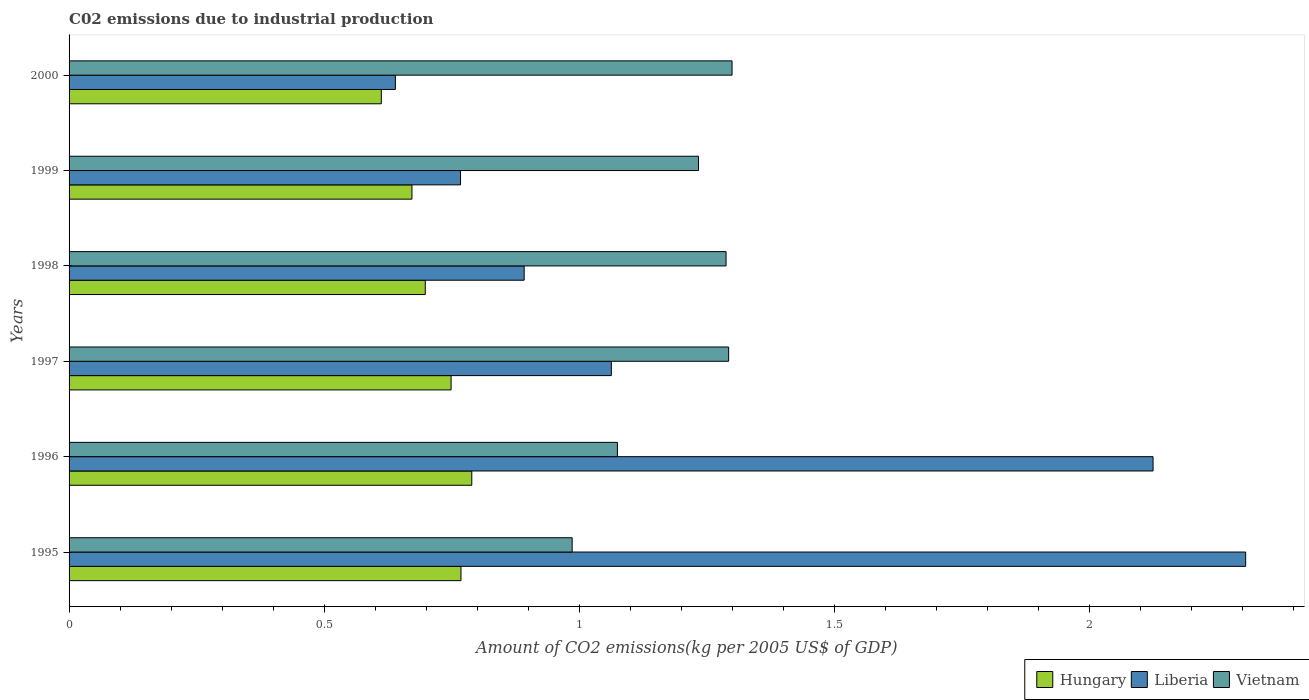How many different coloured bars are there?
Ensure brevity in your answer.  3. Are the number of bars per tick equal to the number of legend labels?
Provide a succinct answer. Yes. Are the number of bars on each tick of the Y-axis equal?
Make the answer very short. Yes. How many bars are there on the 5th tick from the top?
Your answer should be very brief. 3. How many bars are there on the 5th tick from the bottom?
Provide a succinct answer. 3. What is the amount of CO2 emitted due to industrial production in Liberia in 1996?
Your answer should be compact. 2.12. Across all years, what is the maximum amount of CO2 emitted due to industrial production in Hungary?
Ensure brevity in your answer.  0.79. Across all years, what is the minimum amount of CO2 emitted due to industrial production in Liberia?
Your response must be concise. 0.64. In which year was the amount of CO2 emitted due to industrial production in Vietnam maximum?
Provide a succinct answer. 2000. What is the total amount of CO2 emitted due to industrial production in Hungary in the graph?
Your answer should be compact. 4.29. What is the difference between the amount of CO2 emitted due to industrial production in Vietnam in 1995 and that in 2000?
Ensure brevity in your answer.  -0.31. What is the difference between the amount of CO2 emitted due to industrial production in Hungary in 1997 and the amount of CO2 emitted due to industrial production in Vietnam in 1999?
Offer a very short reply. -0.48. What is the average amount of CO2 emitted due to industrial production in Liberia per year?
Ensure brevity in your answer.  1.3. In the year 1995, what is the difference between the amount of CO2 emitted due to industrial production in Liberia and amount of CO2 emitted due to industrial production in Hungary?
Your response must be concise. 1.54. In how many years, is the amount of CO2 emitted due to industrial production in Vietnam greater than 1 kg?
Make the answer very short. 5. What is the ratio of the amount of CO2 emitted due to industrial production in Hungary in 1996 to that in 1999?
Your response must be concise. 1.17. Is the amount of CO2 emitted due to industrial production in Vietnam in 1995 less than that in 1999?
Your answer should be very brief. Yes. What is the difference between the highest and the second highest amount of CO2 emitted due to industrial production in Hungary?
Your answer should be compact. 0.02. What is the difference between the highest and the lowest amount of CO2 emitted due to industrial production in Hungary?
Provide a succinct answer. 0.18. Is the sum of the amount of CO2 emitted due to industrial production in Hungary in 1998 and 2000 greater than the maximum amount of CO2 emitted due to industrial production in Liberia across all years?
Your response must be concise. No. What does the 1st bar from the top in 1998 represents?
Make the answer very short. Vietnam. What does the 2nd bar from the bottom in 1999 represents?
Keep it short and to the point. Liberia. How many bars are there?
Ensure brevity in your answer.  18. Are all the bars in the graph horizontal?
Your answer should be very brief. Yes. What is the difference between two consecutive major ticks on the X-axis?
Provide a succinct answer. 0.5. Are the values on the major ticks of X-axis written in scientific E-notation?
Make the answer very short. No. Does the graph contain any zero values?
Your answer should be compact. No. How are the legend labels stacked?
Provide a short and direct response. Horizontal. What is the title of the graph?
Keep it short and to the point. C02 emissions due to industrial production. Does "Turkmenistan" appear as one of the legend labels in the graph?
Your response must be concise. No. What is the label or title of the X-axis?
Your answer should be compact. Amount of CO2 emissions(kg per 2005 US$ of GDP). What is the label or title of the Y-axis?
Make the answer very short. Years. What is the Amount of CO2 emissions(kg per 2005 US$ of GDP) in Hungary in 1995?
Offer a terse response. 0.77. What is the Amount of CO2 emissions(kg per 2005 US$ of GDP) of Liberia in 1995?
Make the answer very short. 2.31. What is the Amount of CO2 emissions(kg per 2005 US$ of GDP) in Vietnam in 1995?
Keep it short and to the point. 0.99. What is the Amount of CO2 emissions(kg per 2005 US$ of GDP) of Hungary in 1996?
Offer a very short reply. 0.79. What is the Amount of CO2 emissions(kg per 2005 US$ of GDP) of Liberia in 1996?
Ensure brevity in your answer.  2.12. What is the Amount of CO2 emissions(kg per 2005 US$ of GDP) in Vietnam in 1996?
Your response must be concise. 1.07. What is the Amount of CO2 emissions(kg per 2005 US$ of GDP) in Hungary in 1997?
Provide a short and direct response. 0.75. What is the Amount of CO2 emissions(kg per 2005 US$ of GDP) of Liberia in 1997?
Make the answer very short. 1.06. What is the Amount of CO2 emissions(kg per 2005 US$ of GDP) of Vietnam in 1997?
Ensure brevity in your answer.  1.29. What is the Amount of CO2 emissions(kg per 2005 US$ of GDP) in Hungary in 1998?
Your answer should be compact. 0.7. What is the Amount of CO2 emissions(kg per 2005 US$ of GDP) of Liberia in 1998?
Offer a very short reply. 0.89. What is the Amount of CO2 emissions(kg per 2005 US$ of GDP) of Vietnam in 1998?
Keep it short and to the point. 1.29. What is the Amount of CO2 emissions(kg per 2005 US$ of GDP) of Hungary in 1999?
Provide a short and direct response. 0.67. What is the Amount of CO2 emissions(kg per 2005 US$ of GDP) of Liberia in 1999?
Keep it short and to the point. 0.77. What is the Amount of CO2 emissions(kg per 2005 US$ of GDP) of Vietnam in 1999?
Make the answer very short. 1.23. What is the Amount of CO2 emissions(kg per 2005 US$ of GDP) in Hungary in 2000?
Give a very brief answer. 0.61. What is the Amount of CO2 emissions(kg per 2005 US$ of GDP) in Liberia in 2000?
Offer a very short reply. 0.64. What is the Amount of CO2 emissions(kg per 2005 US$ of GDP) in Vietnam in 2000?
Make the answer very short. 1.3. Across all years, what is the maximum Amount of CO2 emissions(kg per 2005 US$ of GDP) of Hungary?
Your answer should be very brief. 0.79. Across all years, what is the maximum Amount of CO2 emissions(kg per 2005 US$ of GDP) of Liberia?
Make the answer very short. 2.31. Across all years, what is the maximum Amount of CO2 emissions(kg per 2005 US$ of GDP) of Vietnam?
Offer a terse response. 1.3. Across all years, what is the minimum Amount of CO2 emissions(kg per 2005 US$ of GDP) of Hungary?
Give a very brief answer. 0.61. Across all years, what is the minimum Amount of CO2 emissions(kg per 2005 US$ of GDP) of Liberia?
Make the answer very short. 0.64. Across all years, what is the minimum Amount of CO2 emissions(kg per 2005 US$ of GDP) in Vietnam?
Provide a succinct answer. 0.99. What is the total Amount of CO2 emissions(kg per 2005 US$ of GDP) of Hungary in the graph?
Provide a succinct answer. 4.29. What is the total Amount of CO2 emissions(kg per 2005 US$ of GDP) in Liberia in the graph?
Give a very brief answer. 7.79. What is the total Amount of CO2 emissions(kg per 2005 US$ of GDP) in Vietnam in the graph?
Your answer should be compact. 7.17. What is the difference between the Amount of CO2 emissions(kg per 2005 US$ of GDP) of Hungary in 1995 and that in 1996?
Keep it short and to the point. -0.02. What is the difference between the Amount of CO2 emissions(kg per 2005 US$ of GDP) of Liberia in 1995 and that in 1996?
Offer a very short reply. 0.18. What is the difference between the Amount of CO2 emissions(kg per 2005 US$ of GDP) in Vietnam in 1995 and that in 1996?
Keep it short and to the point. -0.09. What is the difference between the Amount of CO2 emissions(kg per 2005 US$ of GDP) of Hungary in 1995 and that in 1997?
Ensure brevity in your answer.  0.02. What is the difference between the Amount of CO2 emissions(kg per 2005 US$ of GDP) of Liberia in 1995 and that in 1997?
Your answer should be very brief. 1.24. What is the difference between the Amount of CO2 emissions(kg per 2005 US$ of GDP) in Vietnam in 1995 and that in 1997?
Your answer should be compact. -0.31. What is the difference between the Amount of CO2 emissions(kg per 2005 US$ of GDP) of Hungary in 1995 and that in 1998?
Ensure brevity in your answer.  0.07. What is the difference between the Amount of CO2 emissions(kg per 2005 US$ of GDP) in Liberia in 1995 and that in 1998?
Your answer should be very brief. 1.41. What is the difference between the Amount of CO2 emissions(kg per 2005 US$ of GDP) of Vietnam in 1995 and that in 1998?
Keep it short and to the point. -0.3. What is the difference between the Amount of CO2 emissions(kg per 2005 US$ of GDP) in Hungary in 1995 and that in 1999?
Make the answer very short. 0.1. What is the difference between the Amount of CO2 emissions(kg per 2005 US$ of GDP) in Liberia in 1995 and that in 1999?
Offer a terse response. 1.54. What is the difference between the Amount of CO2 emissions(kg per 2005 US$ of GDP) of Vietnam in 1995 and that in 1999?
Keep it short and to the point. -0.25. What is the difference between the Amount of CO2 emissions(kg per 2005 US$ of GDP) in Hungary in 1995 and that in 2000?
Ensure brevity in your answer.  0.16. What is the difference between the Amount of CO2 emissions(kg per 2005 US$ of GDP) in Liberia in 1995 and that in 2000?
Offer a very short reply. 1.67. What is the difference between the Amount of CO2 emissions(kg per 2005 US$ of GDP) of Vietnam in 1995 and that in 2000?
Make the answer very short. -0.31. What is the difference between the Amount of CO2 emissions(kg per 2005 US$ of GDP) in Hungary in 1996 and that in 1997?
Offer a terse response. 0.04. What is the difference between the Amount of CO2 emissions(kg per 2005 US$ of GDP) in Liberia in 1996 and that in 1997?
Offer a terse response. 1.06. What is the difference between the Amount of CO2 emissions(kg per 2005 US$ of GDP) of Vietnam in 1996 and that in 1997?
Keep it short and to the point. -0.22. What is the difference between the Amount of CO2 emissions(kg per 2005 US$ of GDP) of Hungary in 1996 and that in 1998?
Provide a succinct answer. 0.09. What is the difference between the Amount of CO2 emissions(kg per 2005 US$ of GDP) of Liberia in 1996 and that in 1998?
Provide a succinct answer. 1.23. What is the difference between the Amount of CO2 emissions(kg per 2005 US$ of GDP) in Vietnam in 1996 and that in 1998?
Ensure brevity in your answer.  -0.21. What is the difference between the Amount of CO2 emissions(kg per 2005 US$ of GDP) in Hungary in 1996 and that in 1999?
Make the answer very short. 0.12. What is the difference between the Amount of CO2 emissions(kg per 2005 US$ of GDP) in Liberia in 1996 and that in 1999?
Offer a terse response. 1.36. What is the difference between the Amount of CO2 emissions(kg per 2005 US$ of GDP) in Vietnam in 1996 and that in 1999?
Keep it short and to the point. -0.16. What is the difference between the Amount of CO2 emissions(kg per 2005 US$ of GDP) in Hungary in 1996 and that in 2000?
Your answer should be very brief. 0.18. What is the difference between the Amount of CO2 emissions(kg per 2005 US$ of GDP) in Liberia in 1996 and that in 2000?
Your response must be concise. 1.48. What is the difference between the Amount of CO2 emissions(kg per 2005 US$ of GDP) of Vietnam in 1996 and that in 2000?
Give a very brief answer. -0.22. What is the difference between the Amount of CO2 emissions(kg per 2005 US$ of GDP) in Hungary in 1997 and that in 1998?
Provide a short and direct response. 0.05. What is the difference between the Amount of CO2 emissions(kg per 2005 US$ of GDP) of Liberia in 1997 and that in 1998?
Provide a succinct answer. 0.17. What is the difference between the Amount of CO2 emissions(kg per 2005 US$ of GDP) of Vietnam in 1997 and that in 1998?
Keep it short and to the point. 0.01. What is the difference between the Amount of CO2 emissions(kg per 2005 US$ of GDP) of Hungary in 1997 and that in 1999?
Offer a very short reply. 0.08. What is the difference between the Amount of CO2 emissions(kg per 2005 US$ of GDP) in Liberia in 1997 and that in 1999?
Your response must be concise. 0.3. What is the difference between the Amount of CO2 emissions(kg per 2005 US$ of GDP) in Vietnam in 1997 and that in 1999?
Give a very brief answer. 0.06. What is the difference between the Amount of CO2 emissions(kg per 2005 US$ of GDP) of Hungary in 1997 and that in 2000?
Offer a terse response. 0.14. What is the difference between the Amount of CO2 emissions(kg per 2005 US$ of GDP) in Liberia in 1997 and that in 2000?
Provide a short and direct response. 0.42. What is the difference between the Amount of CO2 emissions(kg per 2005 US$ of GDP) of Vietnam in 1997 and that in 2000?
Your answer should be compact. -0.01. What is the difference between the Amount of CO2 emissions(kg per 2005 US$ of GDP) in Hungary in 1998 and that in 1999?
Ensure brevity in your answer.  0.03. What is the difference between the Amount of CO2 emissions(kg per 2005 US$ of GDP) of Liberia in 1998 and that in 1999?
Your response must be concise. 0.12. What is the difference between the Amount of CO2 emissions(kg per 2005 US$ of GDP) in Vietnam in 1998 and that in 1999?
Keep it short and to the point. 0.05. What is the difference between the Amount of CO2 emissions(kg per 2005 US$ of GDP) of Hungary in 1998 and that in 2000?
Make the answer very short. 0.09. What is the difference between the Amount of CO2 emissions(kg per 2005 US$ of GDP) in Liberia in 1998 and that in 2000?
Keep it short and to the point. 0.25. What is the difference between the Amount of CO2 emissions(kg per 2005 US$ of GDP) in Vietnam in 1998 and that in 2000?
Provide a short and direct response. -0.01. What is the difference between the Amount of CO2 emissions(kg per 2005 US$ of GDP) of Hungary in 1999 and that in 2000?
Provide a short and direct response. 0.06. What is the difference between the Amount of CO2 emissions(kg per 2005 US$ of GDP) of Liberia in 1999 and that in 2000?
Your response must be concise. 0.13. What is the difference between the Amount of CO2 emissions(kg per 2005 US$ of GDP) of Vietnam in 1999 and that in 2000?
Your response must be concise. -0.07. What is the difference between the Amount of CO2 emissions(kg per 2005 US$ of GDP) in Hungary in 1995 and the Amount of CO2 emissions(kg per 2005 US$ of GDP) in Liberia in 1996?
Give a very brief answer. -1.36. What is the difference between the Amount of CO2 emissions(kg per 2005 US$ of GDP) in Hungary in 1995 and the Amount of CO2 emissions(kg per 2005 US$ of GDP) in Vietnam in 1996?
Make the answer very short. -0.31. What is the difference between the Amount of CO2 emissions(kg per 2005 US$ of GDP) of Liberia in 1995 and the Amount of CO2 emissions(kg per 2005 US$ of GDP) of Vietnam in 1996?
Your response must be concise. 1.23. What is the difference between the Amount of CO2 emissions(kg per 2005 US$ of GDP) of Hungary in 1995 and the Amount of CO2 emissions(kg per 2005 US$ of GDP) of Liberia in 1997?
Give a very brief answer. -0.29. What is the difference between the Amount of CO2 emissions(kg per 2005 US$ of GDP) in Hungary in 1995 and the Amount of CO2 emissions(kg per 2005 US$ of GDP) in Vietnam in 1997?
Your response must be concise. -0.52. What is the difference between the Amount of CO2 emissions(kg per 2005 US$ of GDP) of Liberia in 1995 and the Amount of CO2 emissions(kg per 2005 US$ of GDP) of Vietnam in 1997?
Offer a terse response. 1.01. What is the difference between the Amount of CO2 emissions(kg per 2005 US$ of GDP) in Hungary in 1995 and the Amount of CO2 emissions(kg per 2005 US$ of GDP) in Liberia in 1998?
Make the answer very short. -0.12. What is the difference between the Amount of CO2 emissions(kg per 2005 US$ of GDP) of Hungary in 1995 and the Amount of CO2 emissions(kg per 2005 US$ of GDP) of Vietnam in 1998?
Ensure brevity in your answer.  -0.52. What is the difference between the Amount of CO2 emissions(kg per 2005 US$ of GDP) of Liberia in 1995 and the Amount of CO2 emissions(kg per 2005 US$ of GDP) of Vietnam in 1998?
Your answer should be very brief. 1.02. What is the difference between the Amount of CO2 emissions(kg per 2005 US$ of GDP) in Hungary in 1995 and the Amount of CO2 emissions(kg per 2005 US$ of GDP) in Liberia in 1999?
Make the answer very short. 0. What is the difference between the Amount of CO2 emissions(kg per 2005 US$ of GDP) in Hungary in 1995 and the Amount of CO2 emissions(kg per 2005 US$ of GDP) in Vietnam in 1999?
Give a very brief answer. -0.47. What is the difference between the Amount of CO2 emissions(kg per 2005 US$ of GDP) of Liberia in 1995 and the Amount of CO2 emissions(kg per 2005 US$ of GDP) of Vietnam in 1999?
Your answer should be compact. 1.07. What is the difference between the Amount of CO2 emissions(kg per 2005 US$ of GDP) of Hungary in 1995 and the Amount of CO2 emissions(kg per 2005 US$ of GDP) of Liberia in 2000?
Ensure brevity in your answer.  0.13. What is the difference between the Amount of CO2 emissions(kg per 2005 US$ of GDP) in Hungary in 1995 and the Amount of CO2 emissions(kg per 2005 US$ of GDP) in Vietnam in 2000?
Offer a very short reply. -0.53. What is the difference between the Amount of CO2 emissions(kg per 2005 US$ of GDP) of Liberia in 1995 and the Amount of CO2 emissions(kg per 2005 US$ of GDP) of Vietnam in 2000?
Provide a short and direct response. 1.01. What is the difference between the Amount of CO2 emissions(kg per 2005 US$ of GDP) in Hungary in 1996 and the Amount of CO2 emissions(kg per 2005 US$ of GDP) in Liberia in 1997?
Provide a short and direct response. -0.27. What is the difference between the Amount of CO2 emissions(kg per 2005 US$ of GDP) in Hungary in 1996 and the Amount of CO2 emissions(kg per 2005 US$ of GDP) in Vietnam in 1997?
Provide a succinct answer. -0.5. What is the difference between the Amount of CO2 emissions(kg per 2005 US$ of GDP) in Liberia in 1996 and the Amount of CO2 emissions(kg per 2005 US$ of GDP) in Vietnam in 1997?
Your answer should be compact. 0.83. What is the difference between the Amount of CO2 emissions(kg per 2005 US$ of GDP) of Hungary in 1996 and the Amount of CO2 emissions(kg per 2005 US$ of GDP) of Liberia in 1998?
Your answer should be very brief. -0.1. What is the difference between the Amount of CO2 emissions(kg per 2005 US$ of GDP) of Hungary in 1996 and the Amount of CO2 emissions(kg per 2005 US$ of GDP) of Vietnam in 1998?
Keep it short and to the point. -0.5. What is the difference between the Amount of CO2 emissions(kg per 2005 US$ of GDP) of Liberia in 1996 and the Amount of CO2 emissions(kg per 2005 US$ of GDP) of Vietnam in 1998?
Provide a succinct answer. 0.84. What is the difference between the Amount of CO2 emissions(kg per 2005 US$ of GDP) in Hungary in 1996 and the Amount of CO2 emissions(kg per 2005 US$ of GDP) in Liberia in 1999?
Ensure brevity in your answer.  0.02. What is the difference between the Amount of CO2 emissions(kg per 2005 US$ of GDP) in Hungary in 1996 and the Amount of CO2 emissions(kg per 2005 US$ of GDP) in Vietnam in 1999?
Give a very brief answer. -0.44. What is the difference between the Amount of CO2 emissions(kg per 2005 US$ of GDP) of Liberia in 1996 and the Amount of CO2 emissions(kg per 2005 US$ of GDP) of Vietnam in 1999?
Keep it short and to the point. 0.89. What is the difference between the Amount of CO2 emissions(kg per 2005 US$ of GDP) of Hungary in 1996 and the Amount of CO2 emissions(kg per 2005 US$ of GDP) of Liberia in 2000?
Ensure brevity in your answer.  0.15. What is the difference between the Amount of CO2 emissions(kg per 2005 US$ of GDP) in Hungary in 1996 and the Amount of CO2 emissions(kg per 2005 US$ of GDP) in Vietnam in 2000?
Your response must be concise. -0.51. What is the difference between the Amount of CO2 emissions(kg per 2005 US$ of GDP) of Liberia in 1996 and the Amount of CO2 emissions(kg per 2005 US$ of GDP) of Vietnam in 2000?
Offer a terse response. 0.83. What is the difference between the Amount of CO2 emissions(kg per 2005 US$ of GDP) in Hungary in 1997 and the Amount of CO2 emissions(kg per 2005 US$ of GDP) in Liberia in 1998?
Offer a very short reply. -0.14. What is the difference between the Amount of CO2 emissions(kg per 2005 US$ of GDP) of Hungary in 1997 and the Amount of CO2 emissions(kg per 2005 US$ of GDP) of Vietnam in 1998?
Offer a very short reply. -0.54. What is the difference between the Amount of CO2 emissions(kg per 2005 US$ of GDP) of Liberia in 1997 and the Amount of CO2 emissions(kg per 2005 US$ of GDP) of Vietnam in 1998?
Ensure brevity in your answer.  -0.22. What is the difference between the Amount of CO2 emissions(kg per 2005 US$ of GDP) in Hungary in 1997 and the Amount of CO2 emissions(kg per 2005 US$ of GDP) in Liberia in 1999?
Your answer should be compact. -0.02. What is the difference between the Amount of CO2 emissions(kg per 2005 US$ of GDP) in Hungary in 1997 and the Amount of CO2 emissions(kg per 2005 US$ of GDP) in Vietnam in 1999?
Offer a very short reply. -0.48. What is the difference between the Amount of CO2 emissions(kg per 2005 US$ of GDP) in Liberia in 1997 and the Amount of CO2 emissions(kg per 2005 US$ of GDP) in Vietnam in 1999?
Ensure brevity in your answer.  -0.17. What is the difference between the Amount of CO2 emissions(kg per 2005 US$ of GDP) of Hungary in 1997 and the Amount of CO2 emissions(kg per 2005 US$ of GDP) of Liberia in 2000?
Offer a terse response. 0.11. What is the difference between the Amount of CO2 emissions(kg per 2005 US$ of GDP) of Hungary in 1997 and the Amount of CO2 emissions(kg per 2005 US$ of GDP) of Vietnam in 2000?
Ensure brevity in your answer.  -0.55. What is the difference between the Amount of CO2 emissions(kg per 2005 US$ of GDP) of Liberia in 1997 and the Amount of CO2 emissions(kg per 2005 US$ of GDP) of Vietnam in 2000?
Ensure brevity in your answer.  -0.24. What is the difference between the Amount of CO2 emissions(kg per 2005 US$ of GDP) in Hungary in 1998 and the Amount of CO2 emissions(kg per 2005 US$ of GDP) in Liberia in 1999?
Give a very brief answer. -0.07. What is the difference between the Amount of CO2 emissions(kg per 2005 US$ of GDP) of Hungary in 1998 and the Amount of CO2 emissions(kg per 2005 US$ of GDP) of Vietnam in 1999?
Keep it short and to the point. -0.54. What is the difference between the Amount of CO2 emissions(kg per 2005 US$ of GDP) in Liberia in 1998 and the Amount of CO2 emissions(kg per 2005 US$ of GDP) in Vietnam in 1999?
Your response must be concise. -0.34. What is the difference between the Amount of CO2 emissions(kg per 2005 US$ of GDP) in Hungary in 1998 and the Amount of CO2 emissions(kg per 2005 US$ of GDP) in Liberia in 2000?
Provide a succinct answer. 0.06. What is the difference between the Amount of CO2 emissions(kg per 2005 US$ of GDP) of Hungary in 1998 and the Amount of CO2 emissions(kg per 2005 US$ of GDP) of Vietnam in 2000?
Ensure brevity in your answer.  -0.6. What is the difference between the Amount of CO2 emissions(kg per 2005 US$ of GDP) of Liberia in 1998 and the Amount of CO2 emissions(kg per 2005 US$ of GDP) of Vietnam in 2000?
Make the answer very short. -0.41. What is the difference between the Amount of CO2 emissions(kg per 2005 US$ of GDP) of Hungary in 1999 and the Amount of CO2 emissions(kg per 2005 US$ of GDP) of Liberia in 2000?
Give a very brief answer. 0.03. What is the difference between the Amount of CO2 emissions(kg per 2005 US$ of GDP) of Hungary in 1999 and the Amount of CO2 emissions(kg per 2005 US$ of GDP) of Vietnam in 2000?
Give a very brief answer. -0.63. What is the difference between the Amount of CO2 emissions(kg per 2005 US$ of GDP) in Liberia in 1999 and the Amount of CO2 emissions(kg per 2005 US$ of GDP) in Vietnam in 2000?
Offer a very short reply. -0.53. What is the average Amount of CO2 emissions(kg per 2005 US$ of GDP) in Hungary per year?
Your answer should be very brief. 0.71. What is the average Amount of CO2 emissions(kg per 2005 US$ of GDP) in Liberia per year?
Offer a very short reply. 1.3. What is the average Amount of CO2 emissions(kg per 2005 US$ of GDP) in Vietnam per year?
Your answer should be very brief. 1.2. In the year 1995, what is the difference between the Amount of CO2 emissions(kg per 2005 US$ of GDP) in Hungary and Amount of CO2 emissions(kg per 2005 US$ of GDP) in Liberia?
Your answer should be very brief. -1.54. In the year 1995, what is the difference between the Amount of CO2 emissions(kg per 2005 US$ of GDP) of Hungary and Amount of CO2 emissions(kg per 2005 US$ of GDP) of Vietnam?
Your answer should be very brief. -0.22. In the year 1995, what is the difference between the Amount of CO2 emissions(kg per 2005 US$ of GDP) in Liberia and Amount of CO2 emissions(kg per 2005 US$ of GDP) in Vietnam?
Provide a succinct answer. 1.32. In the year 1996, what is the difference between the Amount of CO2 emissions(kg per 2005 US$ of GDP) of Hungary and Amount of CO2 emissions(kg per 2005 US$ of GDP) of Liberia?
Give a very brief answer. -1.34. In the year 1996, what is the difference between the Amount of CO2 emissions(kg per 2005 US$ of GDP) in Hungary and Amount of CO2 emissions(kg per 2005 US$ of GDP) in Vietnam?
Your answer should be very brief. -0.29. In the year 1996, what is the difference between the Amount of CO2 emissions(kg per 2005 US$ of GDP) of Liberia and Amount of CO2 emissions(kg per 2005 US$ of GDP) of Vietnam?
Provide a short and direct response. 1.05. In the year 1997, what is the difference between the Amount of CO2 emissions(kg per 2005 US$ of GDP) in Hungary and Amount of CO2 emissions(kg per 2005 US$ of GDP) in Liberia?
Offer a very short reply. -0.31. In the year 1997, what is the difference between the Amount of CO2 emissions(kg per 2005 US$ of GDP) in Hungary and Amount of CO2 emissions(kg per 2005 US$ of GDP) in Vietnam?
Provide a succinct answer. -0.54. In the year 1997, what is the difference between the Amount of CO2 emissions(kg per 2005 US$ of GDP) of Liberia and Amount of CO2 emissions(kg per 2005 US$ of GDP) of Vietnam?
Your answer should be compact. -0.23. In the year 1998, what is the difference between the Amount of CO2 emissions(kg per 2005 US$ of GDP) of Hungary and Amount of CO2 emissions(kg per 2005 US$ of GDP) of Liberia?
Make the answer very short. -0.19. In the year 1998, what is the difference between the Amount of CO2 emissions(kg per 2005 US$ of GDP) in Hungary and Amount of CO2 emissions(kg per 2005 US$ of GDP) in Vietnam?
Keep it short and to the point. -0.59. In the year 1998, what is the difference between the Amount of CO2 emissions(kg per 2005 US$ of GDP) of Liberia and Amount of CO2 emissions(kg per 2005 US$ of GDP) of Vietnam?
Make the answer very short. -0.4. In the year 1999, what is the difference between the Amount of CO2 emissions(kg per 2005 US$ of GDP) in Hungary and Amount of CO2 emissions(kg per 2005 US$ of GDP) in Liberia?
Your answer should be compact. -0.1. In the year 1999, what is the difference between the Amount of CO2 emissions(kg per 2005 US$ of GDP) in Hungary and Amount of CO2 emissions(kg per 2005 US$ of GDP) in Vietnam?
Your answer should be very brief. -0.56. In the year 1999, what is the difference between the Amount of CO2 emissions(kg per 2005 US$ of GDP) in Liberia and Amount of CO2 emissions(kg per 2005 US$ of GDP) in Vietnam?
Make the answer very short. -0.47. In the year 2000, what is the difference between the Amount of CO2 emissions(kg per 2005 US$ of GDP) of Hungary and Amount of CO2 emissions(kg per 2005 US$ of GDP) of Liberia?
Your response must be concise. -0.03. In the year 2000, what is the difference between the Amount of CO2 emissions(kg per 2005 US$ of GDP) in Hungary and Amount of CO2 emissions(kg per 2005 US$ of GDP) in Vietnam?
Give a very brief answer. -0.69. In the year 2000, what is the difference between the Amount of CO2 emissions(kg per 2005 US$ of GDP) of Liberia and Amount of CO2 emissions(kg per 2005 US$ of GDP) of Vietnam?
Provide a succinct answer. -0.66. What is the ratio of the Amount of CO2 emissions(kg per 2005 US$ of GDP) of Hungary in 1995 to that in 1996?
Your response must be concise. 0.97. What is the ratio of the Amount of CO2 emissions(kg per 2005 US$ of GDP) in Liberia in 1995 to that in 1996?
Your response must be concise. 1.09. What is the ratio of the Amount of CO2 emissions(kg per 2005 US$ of GDP) in Vietnam in 1995 to that in 1996?
Provide a succinct answer. 0.92. What is the ratio of the Amount of CO2 emissions(kg per 2005 US$ of GDP) of Hungary in 1995 to that in 1997?
Your answer should be compact. 1.03. What is the ratio of the Amount of CO2 emissions(kg per 2005 US$ of GDP) of Liberia in 1995 to that in 1997?
Your response must be concise. 2.17. What is the ratio of the Amount of CO2 emissions(kg per 2005 US$ of GDP) of Vietnam in 1995 to that in 1997?
Provide a succinct answer. 0.76. What is the ratio of the Amount of CO2 emissions(kg per 2005 US$ of GDP) of Hungary in 1995 to that in 1998?
Provide a short and direct response. 1.1. What is the ratio of the Amount of CO2 emissions(kg per 2005 US$ of GDP) of Liberia in 1995 to that in 1998?
Offer a very short reply. 2.59. What is the ratio of the Amount of CO2 emissions(kg per 2005 US$ of GDP) in Vietnam in 1995 to that in 1998?
Offer a terse response. 0.77. What is the ratio of the Amount of CO2 emissions(kg per 2005 US$ of GDP) in Hungary in 1995 to that in 1999?
Provide a succinct answer. 1.14. What is the ratio of the Amount of CO2 emissions(kg per 2005 US$ of GDP) in Liberia in 1995 to that in 1999?
Provide a succinct answer. 3.01. What is the ratio of the Amount of CO2 emissions(kg per 2005 US$ of GDP) of Vietnam in 1995 to that in 1999?
Provide a short and direct response. 0.8. What is the ratio of the Amount of CO2 emissions(kg per 2005 US$ of GDP) in Hungary in 1995 to that in 2000?
Offer a terse response. 1.26. What is the ratio of the Amount of CO2 emissions(kg per 2005 US$ of GDP) in Liberia in 1995 to that in 2000?
Ensure brevity in your answer.  3.61. What is the ratio of the Amount of CO2 emissions(kg per 2005 US$ of GDP) of Vietnam in 1995 to that in 2000?
Your answer should be very brief. 0.76. What is the ratio of the Amount of CO2 emissions(kg per 2005 US$ of GDP) of Hungary in 1996 to that in 1997?
Provide a succinct answer. 1.05. What is the ratio of the Amount of CO2 emissions(kg per 2005 US$ of GDP) in Liberia in 1996 to that in 1997?
Provide a short and direct response. 2. What is the ratio of the Amount of CO2 emissions(kg per 2005 US$ of GDP) of Vietnam in 1996 to that in 1997?
Offer a terse response. 0.83. What is the ratio of the Amount of CO2 emissions(kg per 2005 US$ of GDP) of Hungary in 1996 to that in 1998?
Make the answer very short. 1.13. What is the ratio of the Amount of CO2 emissions(kg per 2005 US$ of GDP) of Liberia in 1996 to that in 1998?
Offer a terse response. 2.38. What is the ratio of the Amount of CO2 emissions(kg per 2005 US$ of GDP) of Vietnam in 1996 to that in 1998?
Provide a short and direct response. 0.83. What is the ratio of the Amount of CO2 emissions(kg per 2005 US$ of GDP) in Hungary in 1996 to that in 1999?
Give a very brief answer. 1.17. What is the ratio of the Amount of CO2 emissions(kg per 2005 US$ of GDP) of Liberia in 1996 to that in 1999?
Provide a short and direct response. 2.77. What is the ratio of the Amount of CO2 emissions(kg per 2005 US$ of GDP) of Vietnam in 1996 to that in 1999?
Offer a very short reply. 0.87. What is the ratio of the Amount of CO2 emissions(kg per 2005 US$ of GDP) in Hungary in 1996 to that in 2000?
Keep it short and to the point. 1.29. What is the ratio of the Amount of CO2 emissions(kg per 2005 US$ of GDP) in Liberia in 1996 to that in 2000?
Your answer should be very brief. 3.32. What is the ratio of the Amount of CO2 emissions(kg per 2005 US$ of GDP) in Vietnam in 1996 to that in 2000?
Provide a succinct answer. 0.83. What is the ratio of the Amount of CO2 emissions(kg per 2005 US$ of GDP) of Hungary in 1997 to that in 1998?
Keep it short and to the point. 1.07. What is the ratio of the Amount of CO2 emissions(kg per 2005 US$ of GDP) in Liberia in 1997 to that in 1998?
Your answer should be very brief. 1.19. What is the ratio of the Amount of CO2 emissions(kg per 2005 US$ of GDP) in Hungary in 1997 to that in 1999?
Give a very brief answer. 1.11. What is the ratio of the Amount of CO2 emissions(kg per 2005 US$ of GDP) of Liberia in 1997 to that in 1999?
Keep it short and to the point. 1.39. What is the ratio of the Amount of CO2 emissions(kg per 2005 US$ of GDP) of Vietnam in 1997 to that in 1999?
Your answer should be very brief. 1.05. What is the ratio of the Amount of CO2 emissions(kg per 2005 US$ of GDP) of Hungary in 1997 to that in 2000?
Ensure brevity in your answer.  1.22. What is the ratio of the Amount of CO2 emissions(kg per 2005 US$ of GDP) in Liberia in 1997 to that in 2000?
Your answer should be very brief. 1.66. What is the ratio of the Amount of CO2 emissions(kg per 2005 US$ of GDP) in Vietnam in 1997 to that in 2000?
Your answer should be compact. 0.99. What is the ratio of the Amount of CO2 emissions(kg per 2005 US$ of GDP) in Hungary in 1998 to that in 1999?
Your response must be concise. 1.04. What is the ratio of the Amount of CO2 emissions(kg per 2005 US$ of GDP) of Liberia in 1998 to that in 1999?
Keep it short and to the point. 1.16. What is the ratio of the Amount of CO2 emissions(kg per 2005 US$ of GDP) in Vietnam in 1998 to that in 1999?
Offer a very short reply. 1.04. What is the ratio of the Amount of CO2 emissions(kg per 2005 US$ of GDP) in Hungary in 1998 to that in 2000?
Offer a very short reply. 1.14. What is the ratio of the Amount of CO2 emissions(kg per 2005 US$ of GDP) in Liberia in 1998 to that in 2000?
Your answer should be very brief. 1.39. What is the ratio of the Amount of CO2 emissions(kg per 2005 US$ of GDP) of Vietnam in 1998 to that in 2000?
Provide a succinct answer. 0.99. What is the ratio of the Amount of CO2 emissions(kg per 2005 US$ of GDP) of Hungary in 1999 to that in 2000?
Your answer should be very brief. 1.1. What is the ratio of the Amount of CO2 emissions(kg per 2005 US$ of GDP) of Liberia in 1999 to that in 2000?
Give a very brief answer. 1.2. What is the ratio of the Amount of CO2 emissions(kg per 2005 US$ of GDP) in Vietnam in 1999 to that in 2000?
Ensure brevity in your answer.  0.95. What is the difference between the highest and the second highest Amount of CO2 emissions(kg per 2005 US$ of GDP) in Hungary?
Make the answer very short. 0.02. What is the difference between the highest and the second highest Amount of CO2 emissions(kg per 2005 US$ of GDP) of Liberia?
Offer a very short reply. 0.18. What is the difference between the highest and the second highest Amount of CO2 emissions(kg per 2005 US$ of GDP) in Vietnam?
Give a very brief answer. 0.01. What is the difference between the highest and the lowest Amount of CO2 emissions(kg per 2005 US$ of GDP) of Hungary?
Your answer should be very brief. 0.18. What is the difference between the highest and the lowest Amount of CO2 emissions(kg per 2005 US$ of GDP) in Liberia?
Provide a short and direct response. 1.67. What is the difference between the highest and the lowest Amount of CO2 emissions(kg per 2005 US$ of GDP) of Vietnam?
Make the answer very short. 0.31. 